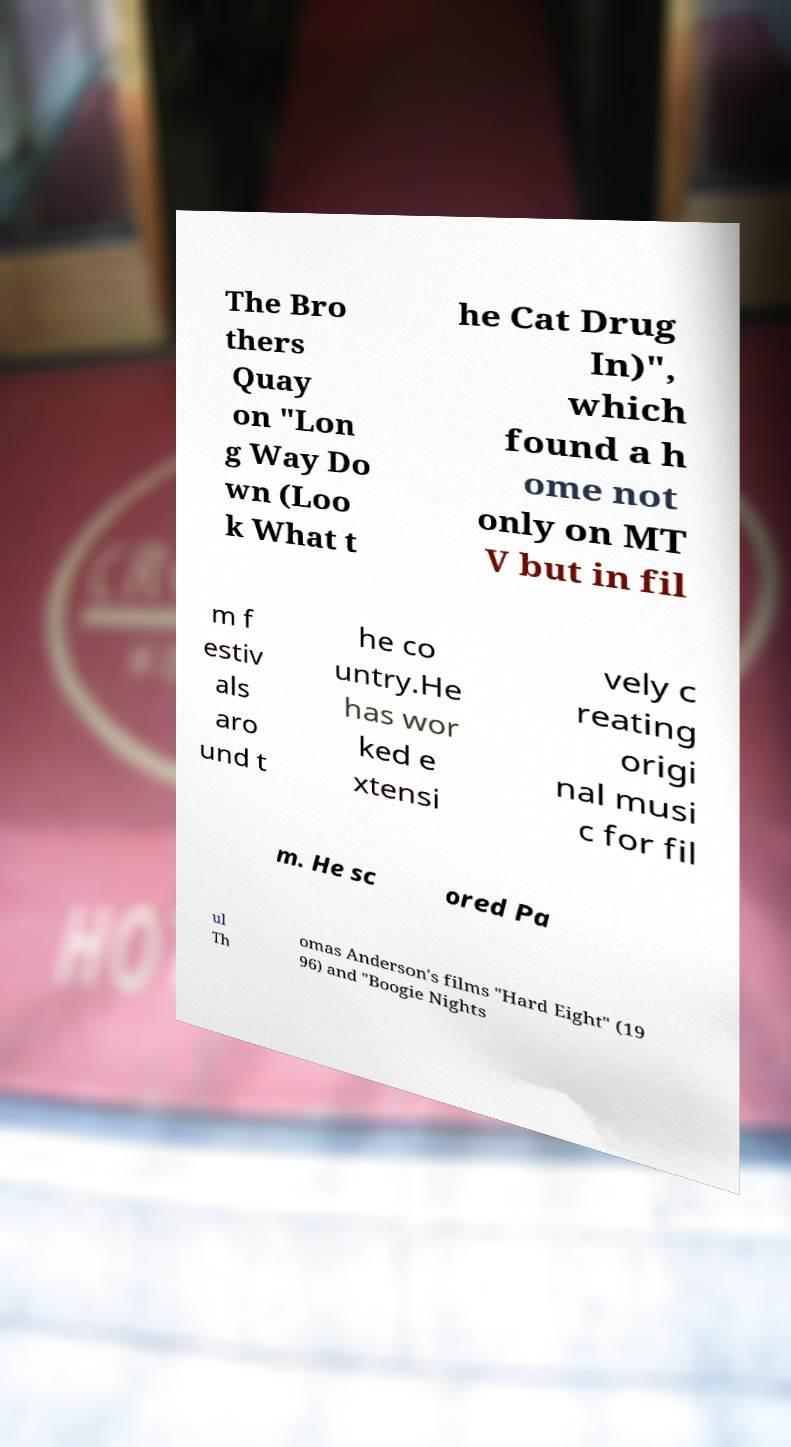Could you assist in decoding the text presented in this image and type it out clearly? The Bro thers Quay on "Lon g Way Do wn (Loo k What t he Cat Drug In)", which found a h ome not only on MT V but in fil m f estiv als aro und t he co untry.He has wor ked e xtensi vely c reating origi nal musi c for fil m. He sc ored Pa ul Th omas Anderson's films "Hard Eight" (19 96) and "Boogie Nights 